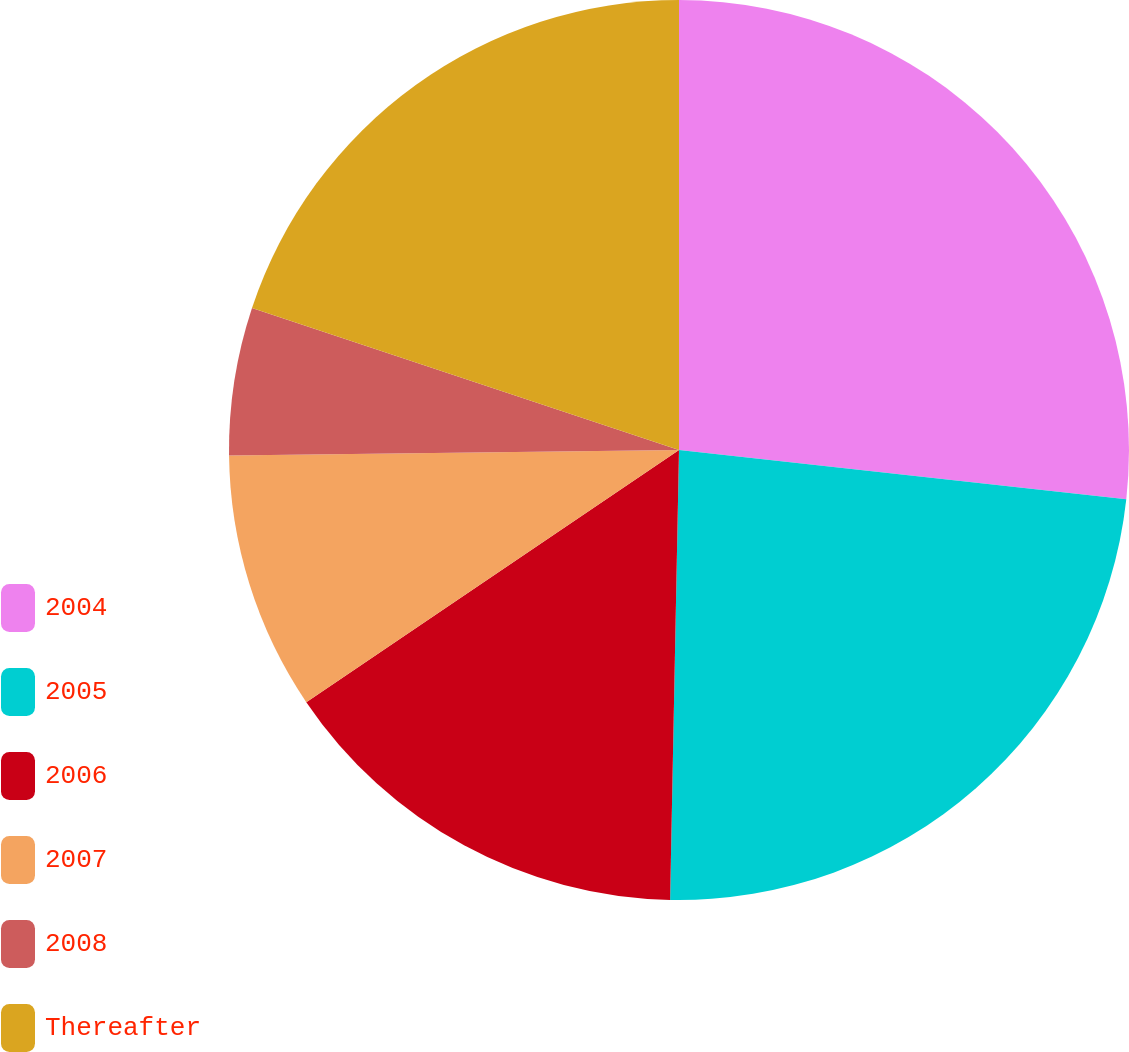Convert chart. <chart><loc_0><loc_0><loc_500><loc_500><pie_chart><fcel>2004<fcel>2005<fcel>2006<fcel>2007<fcel>2008<fcel>Thereafter<nl><fcel>26.75%<fcel>23.57%<fcel>15.22%<fcel>9.27%<fcel>5.31%<fcel>19.89%<nl></chart> 